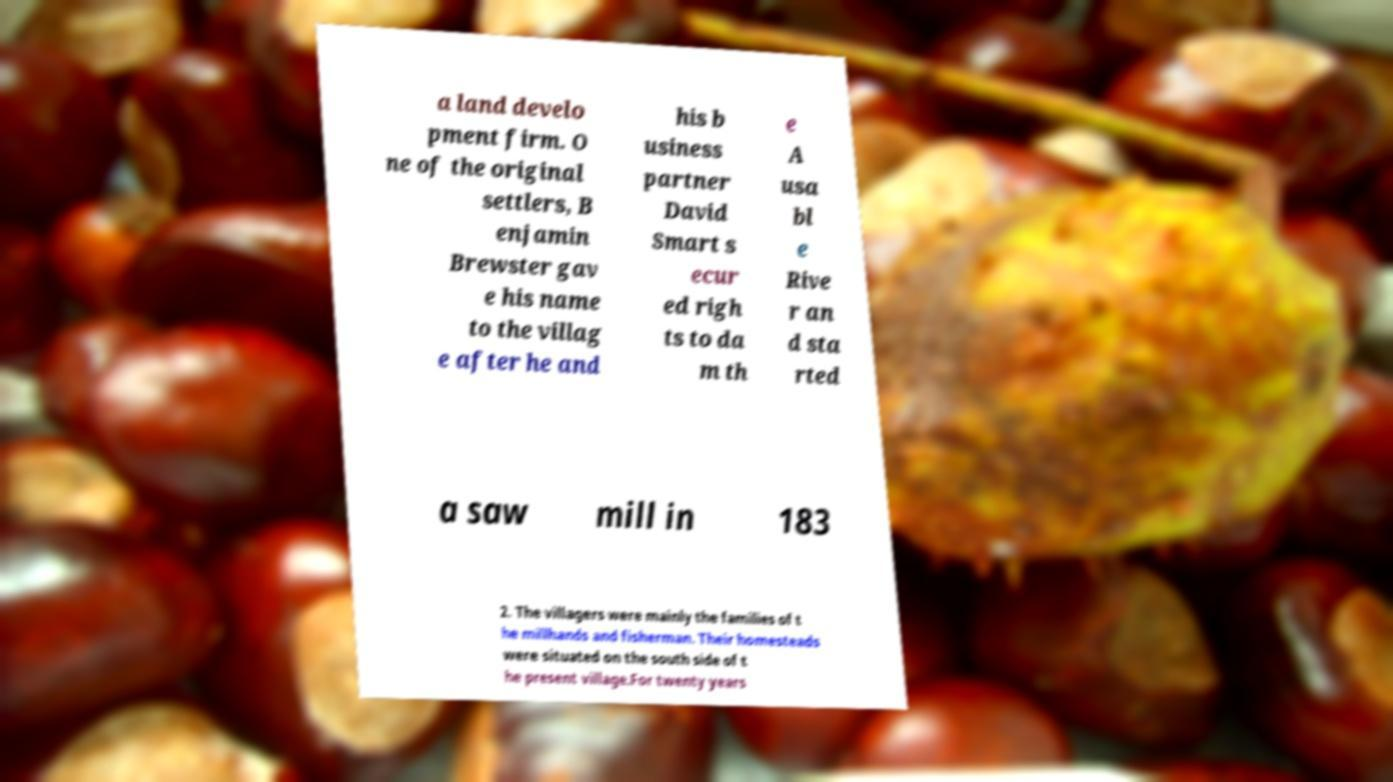Can you read and provide the text displayed in the image?This photo seems to have some interesting text. Can you extract and type it out for me? a land develo pment firm. O ne of the original settlers, B enjamin Brewster gav e his name to the villag e after he and his b usiness partner David Smart s ecur ed righ ts to da m th e A usa bl e Rive r an d sta rted a saw mill in 183 2. The villagers were mainly the families of t he millhands and fisherman. Their homesteads were situated on the south side of t he present village.For twenty years 